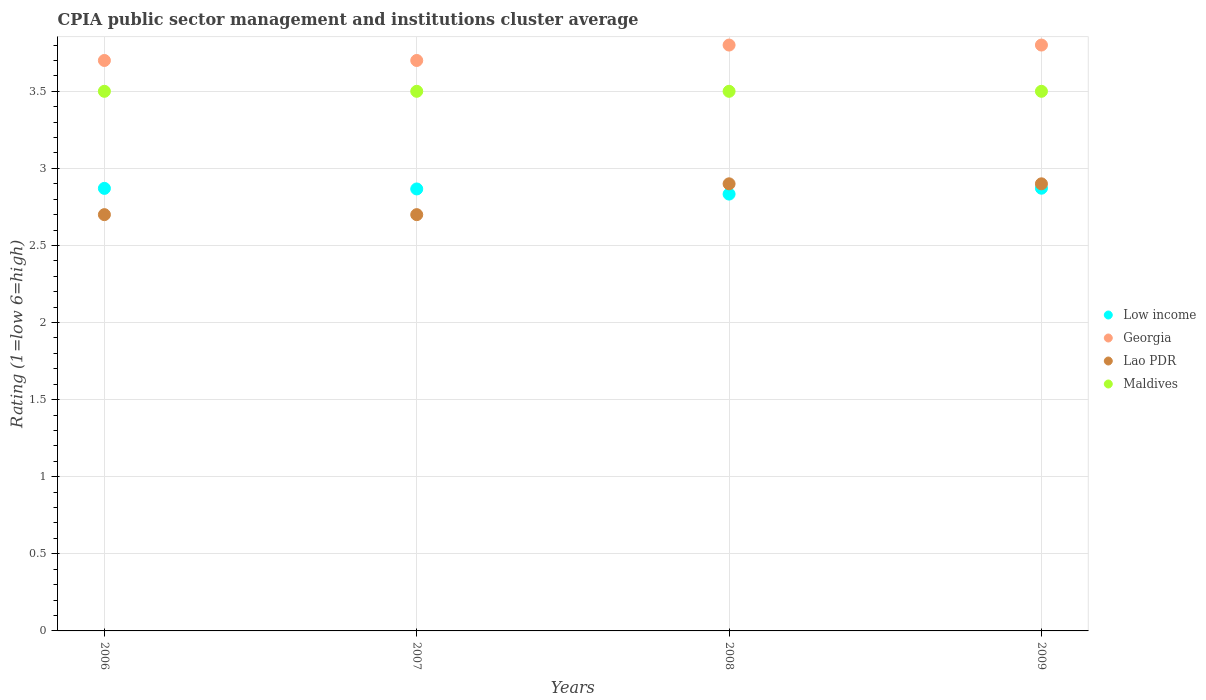How many different coloured dotlines are there?
Your response must be concise. 4. Is the number of dotlines equal to the number of legend labels?
Your answer should be compact. Yes. In which year was the CPIA rating in Georgia maximum?
Your response must be concise. 2008. What is the total CPIA rating in Lao PDR in the graph?
Offer a terse response. 11.2. What is the difference between the CPIA rating in Georgia in 2007 and the CPIA rating in Low income in 2009?
Provide a short and direct response. 0.83. What is the average CPIA rating in Georgia per year?
Offer a very short reply. 3.75. In the year 2008, what is the difference between the CPIA rating in Lao PDR and CPIA rating in Low income?
Make the answer very short. 0.07. What is the ratio of the CPIA rating in Low income in 2007 to that in 2008?
Your answer should be compact. 1.01. What is the difference between the highest and the second highest CPIA rating in Maldives?
Your answer should be compact. 0. What is the difference between the highest and the lowest CPIA rating in Maldives?
Give a very brief answer. 0. Is the sum of the CPIA rating in Maldives in 2007 and 2009 greater than the maximum CPIA rating in Georgia across all years?
Provide a short and direct response. Yes. Is it the case that in every year, the sum of the CPIA rating in Low income and CPIA rating in Maldives  is greater than the sum of CPIA rating in Lao PDR and CPIA rating in Georgia?
Your response must be concise. Yes. Is it the case that in every year, the sum of the CPIA rating in Lao PDR and CPIA rating in Georgia  is greater than the CPIA rating in Low income?
Provide a succinct answer. Yes. What is the difference between two consecutive major ticks on the Y-axis?
Provide a succinct answer. 0.5. Are the values on the major ticks of Y-axis written in scientific E-notation?
Ensure brevity in your answer.  No. Where does the legend appear in the graph?
Offer a very short reply. Center right. How many legend labels are there?
Your answer should be very brief. 4. What is the title of the graph?
Your answer should be compact. CPIA public sector management and institutions cluster average. What is the label or title of the X-axis?
Keep it short and to the point. Years. What is the label or title of the Y-axis?
Make the answer very short. Rating (1=low 6=high). What is the Rating (1=low 6=high) of Low income in 2006?
Give a very brief answer. 2.87. What is the Rating (1=low 6=high) of Georgia in 2006?
Your answer should be compact. 3.7. What is the Rating (1=low 6=high) of Maldives in 2006?
Give a very brief answer. 3.5. What is the Rating (1=low 6=high) in Low income in 2007?
Your answer should be very brief. 2.87. What is the Rating (1=low 6=high) of Georgia in 2007?
Offer a terse response. 3.7. What is the Rating (1=low 6=high) of Low income in 2008?
Keep it short and to the point. 2.83. What is the Rating (1=low 6=high) in Georgia in 2008?
Your answer should be compact. 3.8. What is the Rating (1=low 6=high) of Lao PDR in 2008?
Give a very brief answer. 2.9. What is the Rating (1=low 6=high) in Maldives in 2008?
Give a very brief answer. 3.5. What is the Rating (1=low 6=high) of Low income in 2009?
Keep it short and to the point. 2.87. What is the Rating (1=low 6=high) of Georgia in 2009?
Your response must be concise. 3.8. Across all years, what is the maximum Rating (1=low 6=high) of Low income?
Your answer should be very brief. 2.87. Across all years, what is the maximum Rating (1=low 6=high) in Lao PDR?
Make the answer very short. 2.9. Across all years, what is the minimum Rating (1=low 6=high) in Low income?
Your response must be concise. 2.83. Across all years, what is the minimum Rating (1=low 6=high) of Lao PDR?
Make the answer very short. 2.7. What is the total Rating (1=low 6=high) in Low income in the graph?
Your answer should be compact. 11.44. What is the total Rating (1=low 6=high) of Georgia in the graph?
Your answer should be very brief. 15. What is the total Rating (1=low 6=high) of Lao PDR in the graph?
Provide a short and direct response. 11.2. What is the total Rating (1=low 6=high) in Maldives in the graph?
Offer a terse response. 14. What is the difference between the Rating (1=low 6=high) in Low income in 2006 and that in 2007?
Offer a very short reply. 0. What is the difference between the Rating (1=low 6=high) in Georgia in 2006 and that in 2007?
Provide a succinct answer. 0. What is the difference between the Rating (1=low 6=high) in Lao PDR in 2006 and that in 2007?
Ensure brevity in your answer.  0. What is the difference between the Rating (1=low 6=high) in Low income in 2006 and that in 2008?
Give a very brief answer. 0.04. What is the difference between the Rating (1=low 6=high) of Georgia in 2006 and that in 2008?
Provide a short and direct response. -0.1. What is the difference between the Rating (1=low 6=high) in Lao PDR in 2006 and that in 2008?
Provide a short and direct response. -0.2. What is the difference between the Rating (1=low 6=high) in Low income in 2006 and that in 2009?
Your answer should be very brief. -0. What is the difference between the Rating (1=low 6=high) in Georgia in 2006 and that in 2009?
Offer a terse response. -0.1. What is the difference between the Rating (1=low 6=high) in Maldives in 2006 and that in 2009?
Ensure brevity in your answer.  0. What is the difference between the Rating (1=low 6=high) of Lao PDR in 2007 and that in 2008?
Keep it short and to the point. -0.2. What is the difference between the Rating (1=low 6=high) in Maldives in 2007 and that in 2008?
Your answer should be compact. 0. What is the difference between the Rating (1=low 6=high) of Low income in 2007 and that in 2009?
Provide a short and direct response. -0. What is the difference between the Rating (1=low 6=high) of Georgia in 2007 and that in 2009?
Provide a short and direct response. -0.1. What is the difference between the Rating (1=low 6=high) in Lao PDR in 2007 and that in 2009?
Your response must be concise. -0.2. What is the difference between the Rating (1=low 6=high) in Low income in 2008 and that in 2009?
Keep it short and to the point. -0.04. What is the difference between the Rating (1=low 6=high) in Low income in 2006 and the Rating (1=low 6=high) in Georgia in 2007?
Your answer should be compact. -0.83. What is the difference between the Rating (1=low 6=high) of Low income in 2006 and the Rating (1=low 6=high) of Lao PDR in 2007?
Make the answer very short. 0.17. What is the difference between the Rating (1=low 6=high) in Low income in 2006 and the Rating (1=low 6=high) in Maldives in 2007?
Keep it short and to the point. -0.63. What is the difference between the Rating (1=low 6=high) in Georgia in 2006 and the Rating (1=low 6=high) in Lao PDR in 2007?
Your answer should be very brief. 1. What is the difference between the Rating (1=low 6=high) of Georgia in 2006 and the Rating (1=low 6=high) of Maldives in 2007?
Provide a succinct answer. 0.2. What is the difference between the Rating (1=low 6=high) of Low income in 2006 and the Rating (1=low 6=high) of Georgia in 2008?
Your answer should be compact. -0.93. What is the difference between the Rating (1=low 6=high) in Low income in 2006 and the Rating (1=low 6=high) in Lao PDR in 2008?
Your response must be concise. -0.03. What is the difference between the Rating (1=low 6=high) in Low income in 2006 and the Rating (1=low 6=high) in Maldives in 2008?
Provide a succinct answer. -0.63. What is the difference between the Rating (1=low 6=high) in Georgia in 2006 and the Rating (1=low 6=high) in Lao PDR in 2008?
Offer a terse response. 0.8. What is the difference between the Rating (1=low 6=high) in Lao PDR in 2006 and the Rating (1=low 6=high) in Maldives in 2008?
Your answer should be very brief. -0.8. What is the difference between the Rating (1=low 6=high) of Low income in 2006 and the Rating (1=low 6=high) of Georgia in 2009?
Offer a very short reply. -0.93. What is the difference between the Rating (1=low 6=high) in Low income in 2006 and the Rating (1=low 6=high) in Lao PDR in 2009?
Keep it short and to the point. -0.03. What is the difference between the Rating (1=low 6=high) in Low income in 2006 and the Rating (1=low 6=high) in Maldives in 2009?
Your answer should be very brief. -0.63. What is the difference between the Rating (1=low 6=high) of Georgia in 2006 and the Rating (1=low 6=high) of Maldives in 2009?
Your answer should be very brief. 0.2. What is the difference between the Rating (1=low 6=high) of Low income in 2007 and the Rating (1=low 6=high) of Georgia in 2008?
Offer a terse response. -0.93. What is the difference between the Rating (1=low 6=high) of Low income in 2007 and the Rating (1=low 6=high) of Lao PDR in 2008?
Provide a short and direct response. -0.03. What is the difference between the Rating (1=low 6=high) of Low income in 2007 and the Rating (1=low 6=high) of Maldives in 2008?
Your answer should be very brief. -0.63. What is the difference between the Rating (1=low 6=high) in Georgia in 2007 and the Rating (1=low 6=high) in Lao PDR in 2008?
Provide a succinct answer. 0.8. What is the difference between the Rating (1=low 6=high) in Georgia in 2007 and the Rating (1=low 6=high) in Maldives in 2008?
Give a very brief answer. 0.2. What is the difference between the Rating (1=low 6=high) of Low income in 2007 and the Rating (1=low 6=high) of Georgia in 2009?
Ensure brevity in your answer.  -0.93. What is the difference between the Rating (1=low 6=high) of Low income in 2007 and the Rating (1=low 6=high) of Lao PDR in 2009?
Ensure brevity in your answer.  -0.03. What is the difference between the Rating (1=low 6=high) in Low income in 2007 and the Rating (1=low 6=high) in Maldives in 2009?
Ensure brevity in your answer.  -0.63. What is the difference between the Rating (1=low 6=high) of Georgia in 2007 and the Rating (1=low 6=high) of Lao PDR in 2009?
Your answer should be compact. 0.8. What is the difference between the Rating (1=low 6=high) in Low income in 2008 and the Rating (1=low 6=high) in Georgia in 2009?
Ensure brevity in your answer.  -0.97. What is the difference between the Rating (1=low 6=high) of Low income in 2008 and the Rating (1=low 6=high) of Lao PDR in 2009?
Your answer should be compact. -0.07. What is the difference between the Rating (1=low 6=high) of Georgia in 2008 and the Rating (1=low 6=high) of Lao PDR in 2009?
Your response must be concise. 0.9. What is the difference between the Rating (1=low 6=high) of Georgia in 2008 and the Rating (1=low 6=high) of Maldives in 2009?
Your response must be concise. 0.3. What is the average Rating (1=low 6=high) in Low income per year?
Offer a terse response. 2.86. What is the average Rating (1=low 6=high) in Georgia per year?
Ensure brevity in your answer.  3.75. What is the average Rating (1=low 6=high) in Maldives per year?
Ensure brevity in your answer.  3.5. In the year 2006, what is the difference between the Rating (1=low 6=high) of Low income and Rating (1=low 6=high) of Georgia?
Ensure brevity in your answer.  -0.83. In the year 2006, what is the difference between the Rating (1=low 6=high) in Low income and Rating (1=low 6=high) in Lao PDR?
Offer a very short reply. 0.17. In the year 2006, what is the difference between the Rating (1=low 6=high) in Low income and Rating (1=low 6=high) in Maldives?
Make the answer very short. -0.63. In the year 2006, what is the difference between the Rating (1=low 6=high) of Georgia and Rating (1=low 6=high) of Lao PDR?
Give a very brief answer. 1. In the year 2006, what is the difference between the Rating (1=low 6=high) in Georgia and Rating (1=low 6=high) in Maldives?
Your response must be concise. 0.2. In the year 2007, what is the difference between the Rating (1=low 6=high) of Low income and Rating (1=low 6=high) of Maldives?
Provide a short and direct response. -0.63. In the year 2007, what is the difference between the Rating (1=low 6=high) in Georgia and Rating (1=low 6=high) in Lao PDR?
Your response must be concise. 1. In the year 2007, what is the difference between the Rating (1=low 6=high) in Georgia and Rating (1=low 6=high) in Maldives?
Keep it short and to the point. 0.2. In the year 2007, what is the difference between the Rating (1=low 6=high) of Lao PDR and Rating (1=low 6=high) of Maldives?
Your answer should be compact. -0.8. In the year 2008, what is the difference between the Rating (1=low 6=high) of Low income and Rating (1=low 6=high) of Georgia?
Offer a very short reply. -0.97. In the year 2008, what is the difference between the Rating (1=low 6=high) in Low income and Rating (1=low 6=high) in Lao PDR?
Your answer should be very brief. -0.07. In the year 2008, what is the difference between the Rating (1=low 6=high) in Low income and Rating (1=low 6=high) in Maldives?
Provide a short and direct response. -0.67. In the year 2009, what is the difference between the Rating (1=low 6=high) of Low income and Rating (1=low 6=high) of Georgia?
Make the answer very short. -0.93. In the year 2009, what is the difference between the Rating (1=low 6=high) of Low income and Rating (1=low 6=high) of Lao PDR?
Your response must be concise. -0.03. In the year 2009, what is the difference between the Rating (1=low 6=high) in Low income and Rating (1=low 6=high) in Maldives?
Offer a very short reply. -0.63. In the year 2009, what is the difference between the Rating (1=low 6=high) of Georgia and Rating (1=low 6=high) of Lao PDR?
Ensure brevity in your answer.  0.9. What is the ratio of the Rating (1=low 6=high) of Lao PDR in 2006 to that in 2007?
Offer a very short reply. 1. What is the ratio of the Rating (1=low 6=high) of Maldives in 2006 to that in 2007?
Your answer should be very brief. 1. What is the ratio of the Rating (1=low 6=high) in Low income in 2006 to that in 2008?
Give a very brief answer. 1.01. What is the ratio of the Rating (1=low 6=high) of Georgia in 2006 to that in 2008?
Provide a short and direct response. 0.97. What is the ratio of the Rating (1=low 6=high) of Low income in 2006 to that in 2009?
Your answer should be compact. 1. What is the ratio of the Rating (1=low 6=high) of Georgia in 2006 to that in 2009?
Make the answer very short. 0.97. What is the ratio of the Rating (1=low 6=high) of Low income in 2007 to that in 2008?
Make the answer very short. 1.01. What is the ratio of the Rating (1=low 6=high) in Georgia in 2007 to that in 2008?
Keep it short and to the point. 0.97. What is the ratio of the Rating (1=low 6=high) in Low income in 2007 to that in 2009?
Offer a terse response. 1. What is the ratio of the Rating (1=low 6=high) of Georgia in 2007 to that in 2009?
Give a very brief answer. 0.97. What is the ratio of the Rating (1=low 6=high) of Lao PDR in 2007 to that in 2009?
Your answer should be compact. 0.93. What is the ratio of the Rating (1=low 6=high) in Maldives in 2007 to that in 2009?
Your answer should be compact. 1. What is the ratio of the Rating (1=low 6=high) in Low income in 2008 to that in 2009?
Make the answer very short. 0.99. What is the ratio of the Rating (1=low 6=high) of Georgia in 2008 to that in 2009?
Your response must be concise. 1. What is the ratio of the Rating (1=low 6=high) in Maldives in 2008 to that in 2009?
Your answer should be compact. 1. What is the difference between the highest and the second highest Rating (1=low 6=high) of Low income?
Offer a very short reply. 0. What is the difference between the highest and the second highest Rating (1=low 6=high) of Georgia?
Provide a succinct answer. 0. What is the difference between the highest and the second highest Rating (1=low 6=high) of Lao PDR?
Offer a very short reply. 0. What is the difference between the highest and the lowest Rating (1=low 6=high) of Low income?
Keep it short and to the point. 0.04. What is the difference between the highest and the lowest Rating (1=low 6=high) in Georgia?
Make the answer very short. 0.1. What is the difference between the highest and the lowest Rating (1=low 6=high) in Lao PDR?
Your answer should be compact. 0.2. 